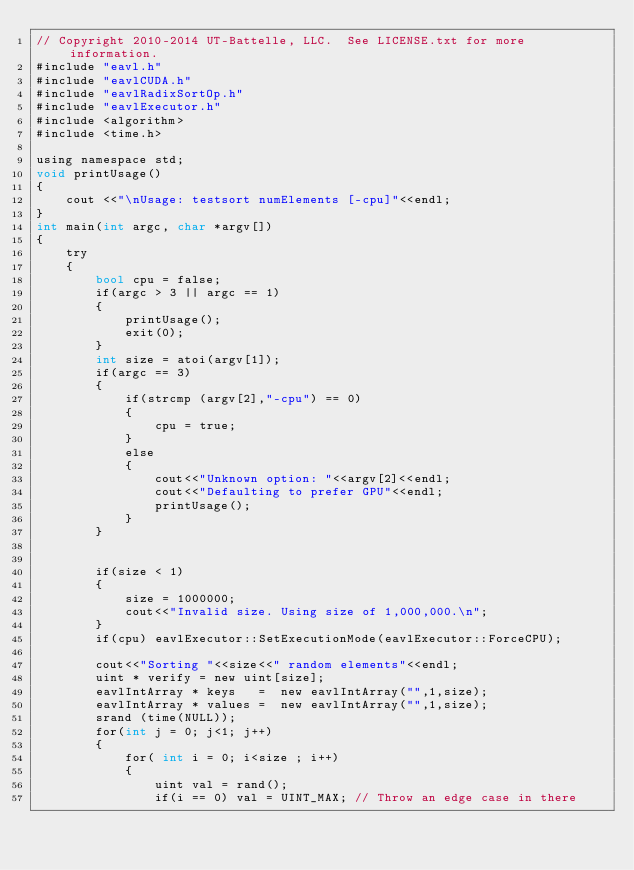Convert code to text. <code><loc_0><loc_0><loc_500><loc_500><_Cuda_>// Copyright 2010-2014 UT-Battelle, LLC.  See LICENSE.txt for more information.
#include "eavl.h"
#include "eavlCUDA.h"
#include "eavlRadixSortOp.h"
#include "eavlExecutor.h"
#include <algorithm>
#include <time.h>

using namespace std;
void printUsage()
{
    cout <<"\nUsage: testsort numElements [-cpu]"<<endl;
}
int main(int argc, char *argv[])
{
    try 
    {   
        bool cpu = false;
        if(argc > 3 || argc == 1)
        {
            printUsage();
            exit(0);
        }
        int size = atoi(argv[1]);
        if(argc == 3)
        {
            if(strcmp (argv[2],"-cpu") == 0)
            {
                cpu = true;
            }
            else 
            {
                cout<<"Unknown option: "<<argv[2]<<endl;
                cout<<"Defaulting to prefer GPU"<<endl;
                printUsage();
            }
        }
        

        if(size < 1) 
        {
            size = 1000000;
            cout<<"Invalid size. Using size of 1,000,000.\n";
        }
        if(cpu) eavlExecutor::SetExecutionMode(eavlExecutor::ForceCPU);

        cout<<"Sorting "<<size<<" random elements"<<endl;
        uint * verify = new uint[size];
        eavlIntArray * keys   =  new eavlIntArray("",1,size);
        eavlIntArray * values =  new eavlIntArray("",1,size);
        srand (time(NULL));
        for(int j = 0; j<1; j++)
        {
            for( int i = 0; i<size ; i++)
            {
                uint val = rand();
                if(i == 0) val = UINT_MAX; // Throw an edge case in there</code> 